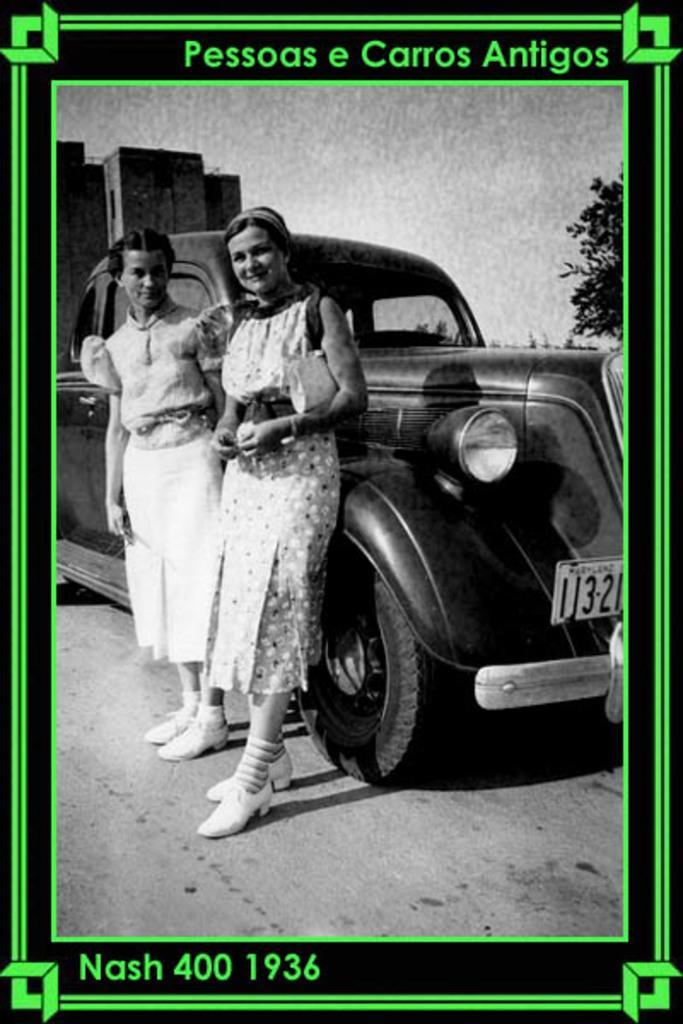Could you give a brief overview of what you see in this image? This is an edited image there are borders at the corners of the image. In the center of the image there is a car. There are two women standing. In the background of the image there is a building. There is a tree. 